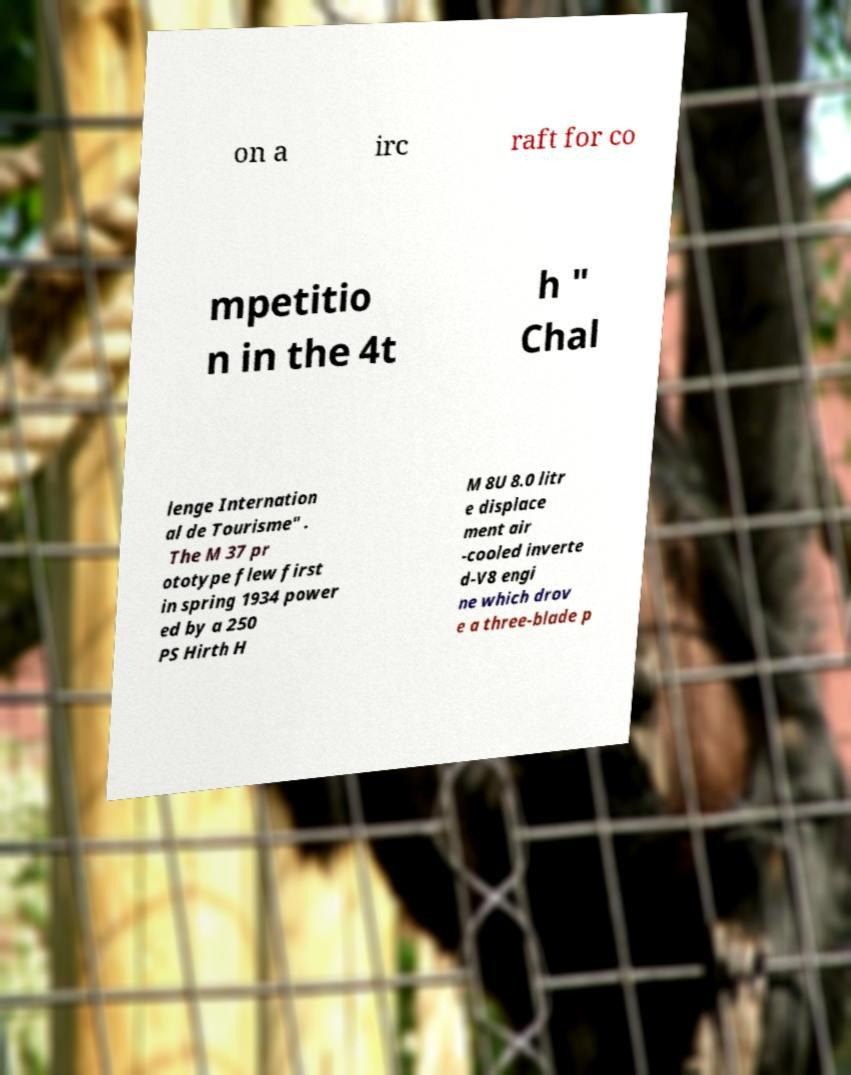Can you read and provide the text displayed in the image?This photo seems to have some interesting text. Can you extract and type it out for me? on a irc raft for co mpetitio n in the 4t h " Chal lenge Internation al de Tourisme" . The M 37 pr ototype flew first in spring 1934 power ed by a 250 PS Hirth H M 8U 8.0 litr e displace ment air -cooled inverte d-V8 engi ne which drov e a three-blade p 